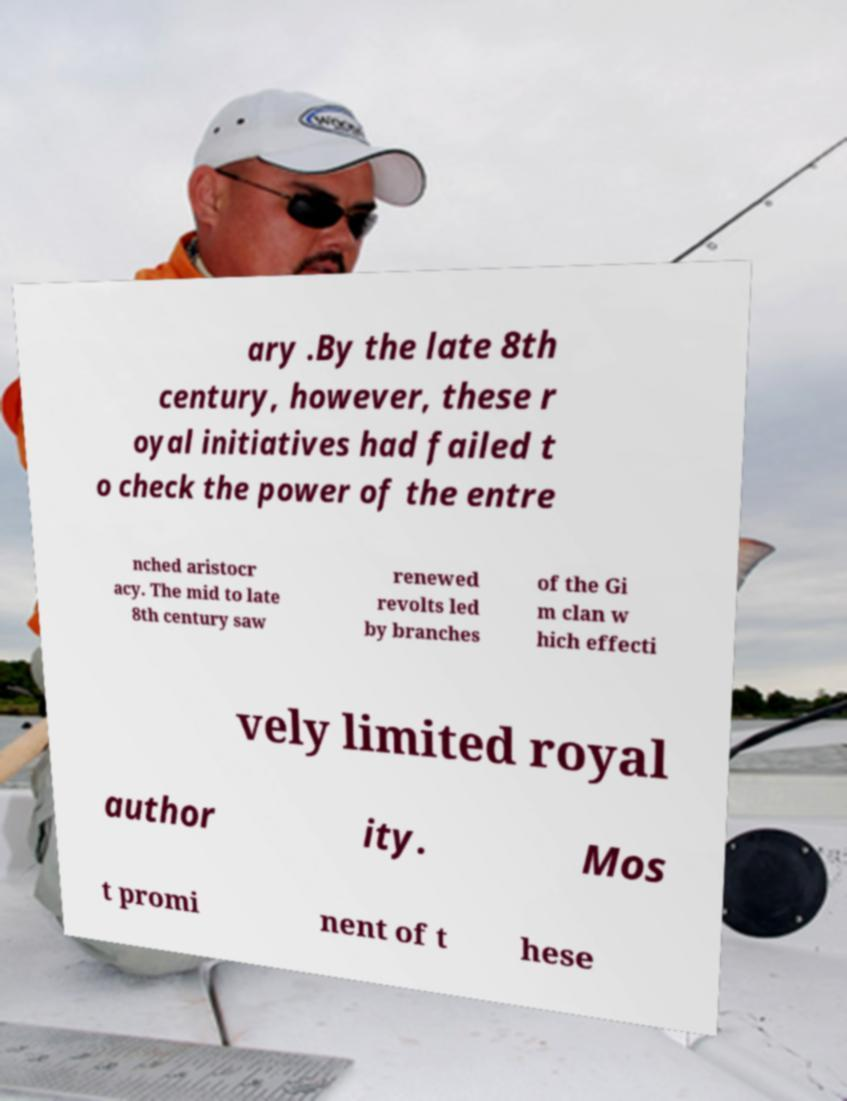Could you assist in decoding the text presented in this image and type it out clearly? ary .By the late 8th century, however, these r oyal initiatives had failed t o check the power of the entre nched aristocr acy. The mid to late 8th century saw renewed revolts led by branches of the Gi m clan w hich effecti vely limited royal author ity. Mos t promi nent of t hese 